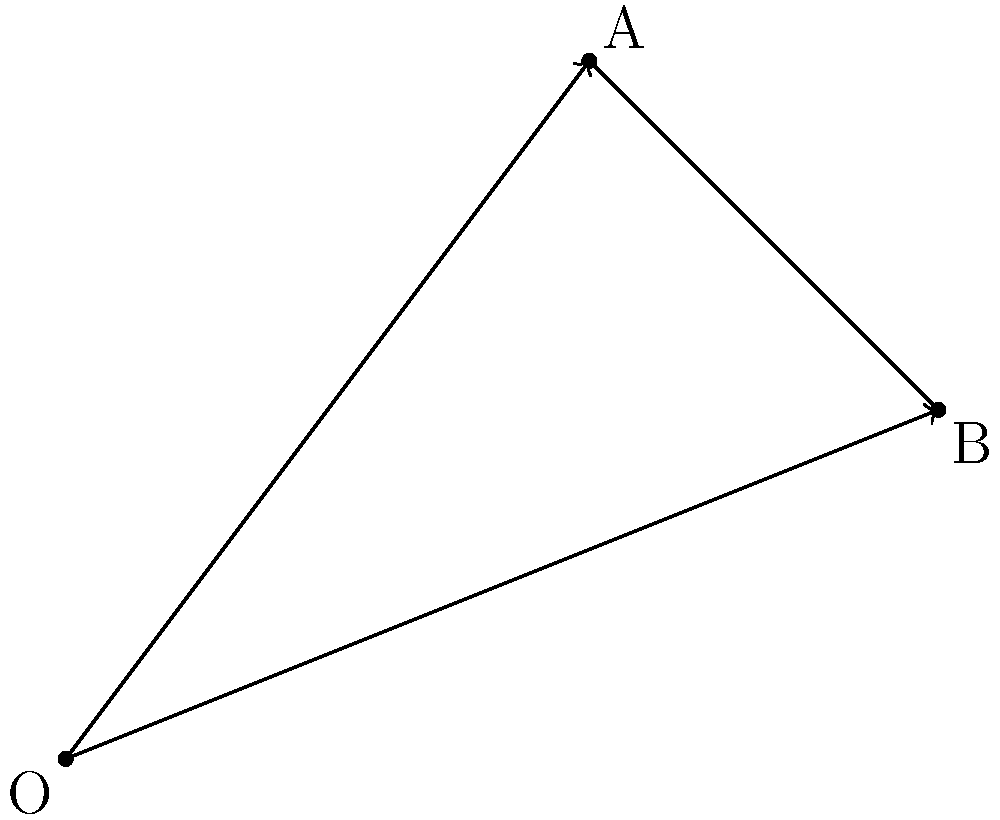В двумерном векторном пространстве даны два вектора: $\vec{a} = (3, 4)$ и $\vec{b} = (5, 2)$. Найдите длину (магнитуду) вектора $\vec{c} = \vec{a} + \vec{b}$, а затем определите нормализованный вектор $\vec{c}_{\text{norm}}$. 1) Сначала найдем координаты вектора $\vec{c}$:
   $\vec{c} = \vec{a} + \vec{b} = (3+5, 4+2) = (8, 6)$

2) Длина (магнитуда) вектора $\vec{c}$ вычисляется по формуле:
   $|\vec{c}| = \sqrt{x^2 + y^2} = \sqrt{8^2 + 6^2} = \sqrt{64 + 36} = \sqrt{100} = 10$

3) Нормализованный вектор получается делением вектора на его длину:
   $\vec{c}_{\text{norm}} = \frac{\vec{c}}{|\vec{c}|} = (\frac{8}{10}, \frac{6}{10}) = (0.8, 0.6)$

4) Проверка: длина нормализованного вектора всегда равна 1
   $|\vec{c}_{\text{norm}}| = \sqrt{0.8^2 + 0.6^2} = \sqrt{0.64 + 0.36} = \sqrt{1} = 1$
Answer: $|\vec{c}| = 10$, $\vec{c}_{\text{norm}} = (0.8, 0.6)$ 